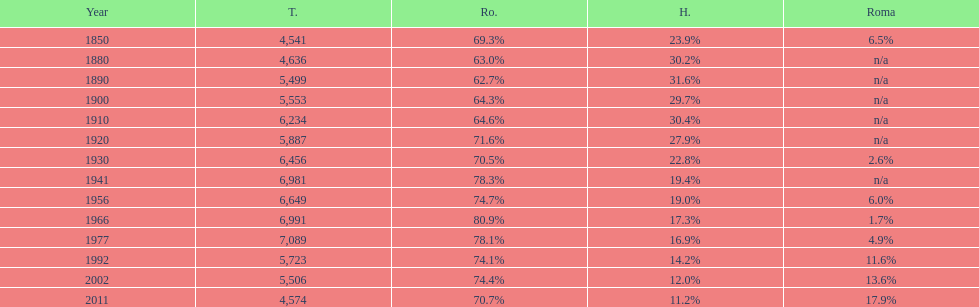What percent of the population were romanians according to the last year on this chart? 70.7%. 